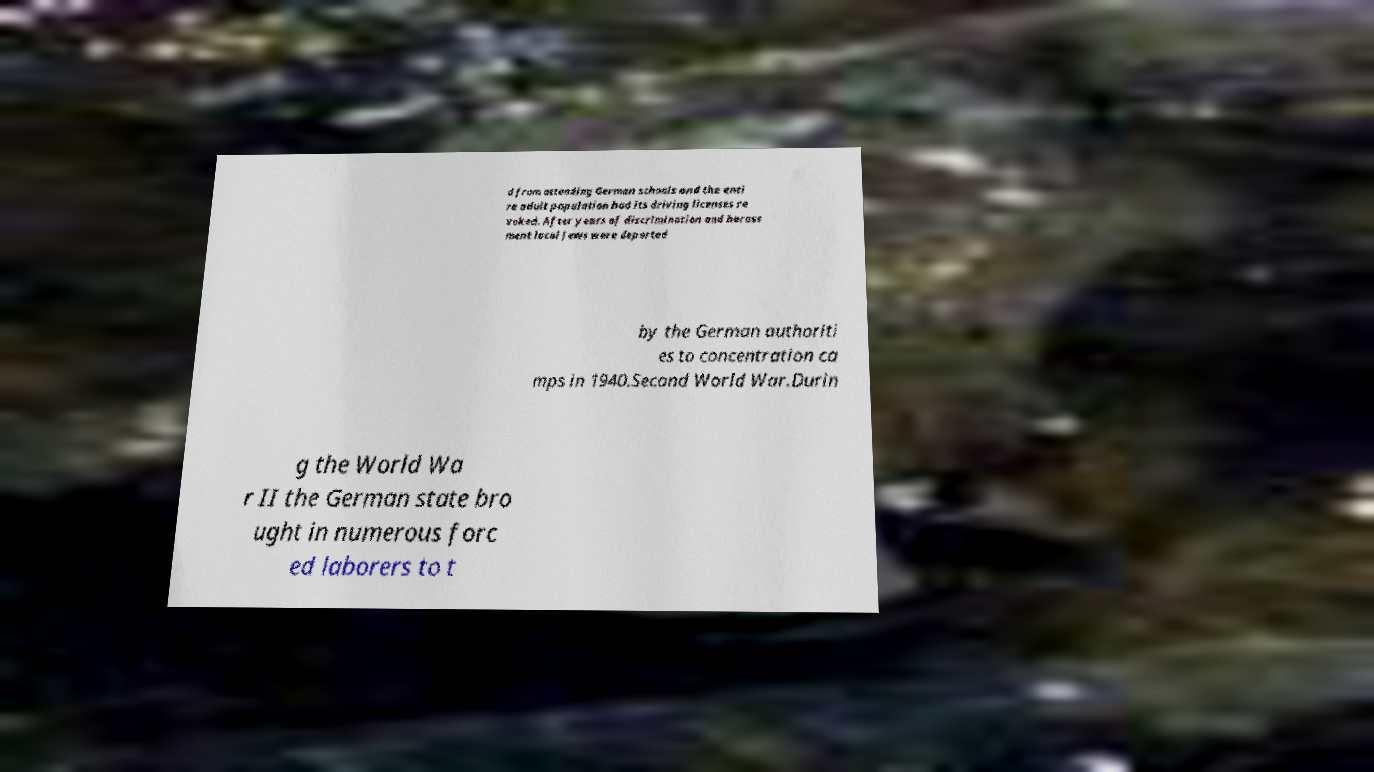There's text embedded in this image that I need extracted. Can you transcribe it verbatim? d from attending German schools and the enti re adult population had its driving licenses re voked. After years of discrimination and harass ment local Jews were deported by the German authoriti es to concentration ca mps in 1940.Second World War.Durin g the World Wa r II the German state bro ught in numerous forc ed laborers to t 